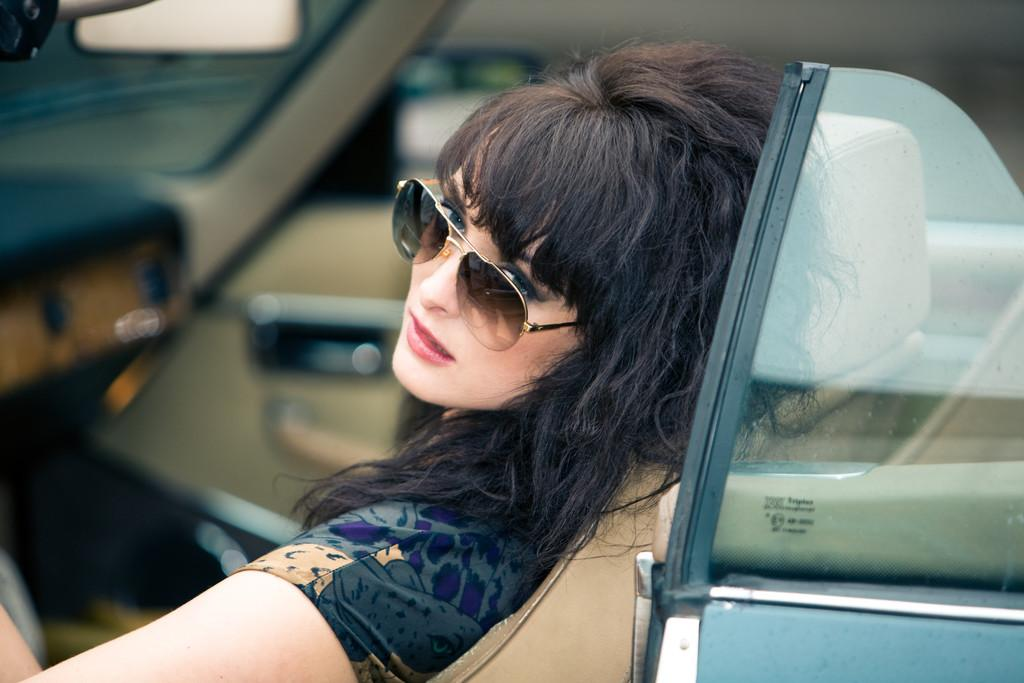What is the woman doing in the image? She is sitting in a car. What can be seen on her face in the image? She is wearing spectacles. What direction is she looking in the image? She is looking at the side. How many lizards are crawling on the curtain in the image? There are no lizards or curtains present in the image. What type of skin condition is visible on her face in the image? There is no mention of any skin condition in the image; she is simply wearing spectacles. 